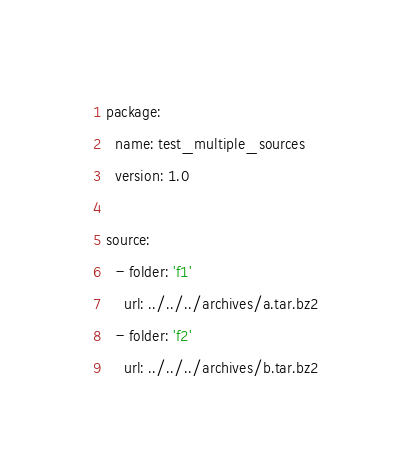<code> <loc_0><loc_0><loc_500><loc_500><_YAML_>package:
  name: test_multiple_sources
  version: 1.0

source:
  - folder: 'f1'
    url: ../../../archives/a.tar.bz2
  - folder: 'f2'
    url: ../../../archives/b.tar.bz2
</code> 